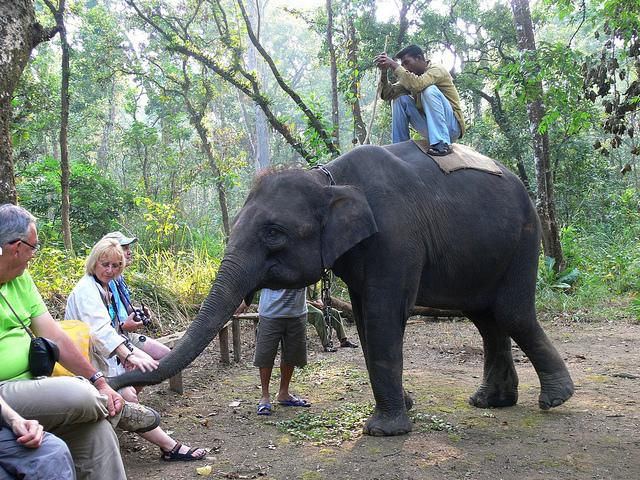What other animal is this animal traditionally afraid of? Please explain your reasoning. mice. The animal is a mouse. 